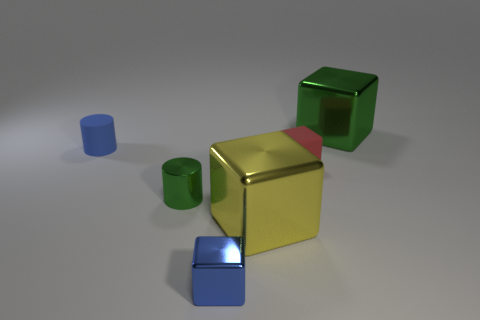Is there another big thing of the same shape as the big green object?
Your response must be concise. Yes. How many large purple shiny objects are the same shape as the tiny red object?
Provide a short and direct response. 0. Is the color of the metal cylinder the same as the matte block?
Provide a succinct answer. No. Are there fewer small purple metal balls than small matte cylinders?
Your answer should be very brief. Yes. There is a small blue object in front of the yellow object; what material is it?
Provide a succinct answer. Metal. There is a green thing that is the same size as the blue cube; what material is it?
Make the answer very short. Metal. What material is the tiny block that is behind the tiny block in front of the green thing to the left of the red thing?
Offer a very short reply. Rubber. There is a green metal thing behind the metallic cylinder; does it have the same size as the yellow block?
Your answer should be compact. Yes. Are there more large matte spheres than blue cylinders?
Give a very brief answer. No. How many big things are either green matte cylinders or blue blocks?
Offer a terse response. 0. 